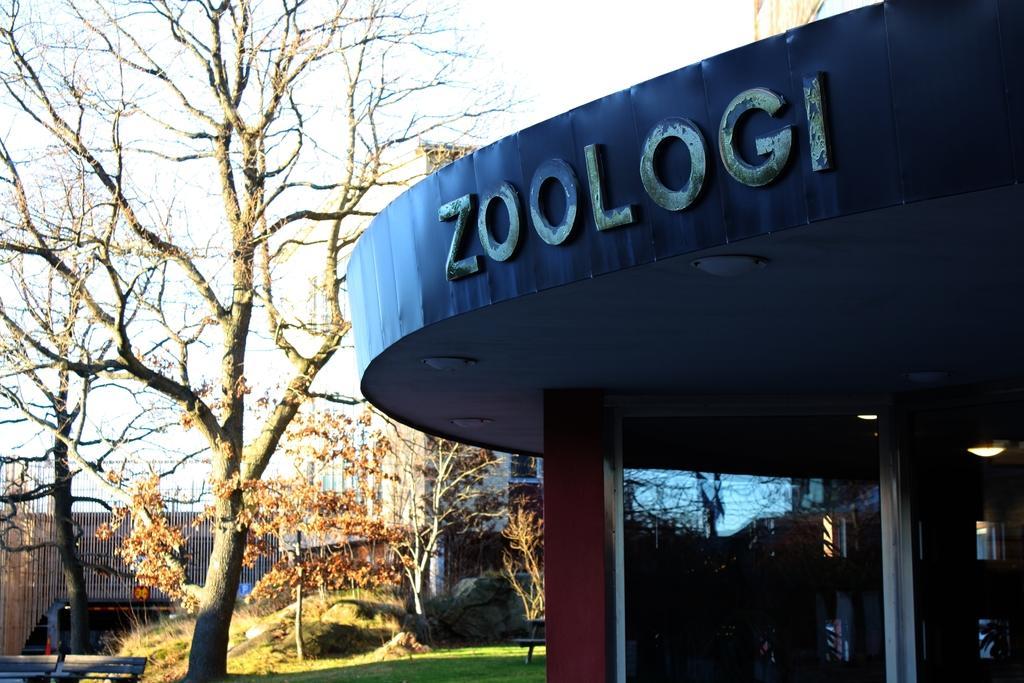In one or two sentences, can you explain what this image depicts? In this image there is a building, there are trees, plants, benches, rocks, and in the background there is sky. 